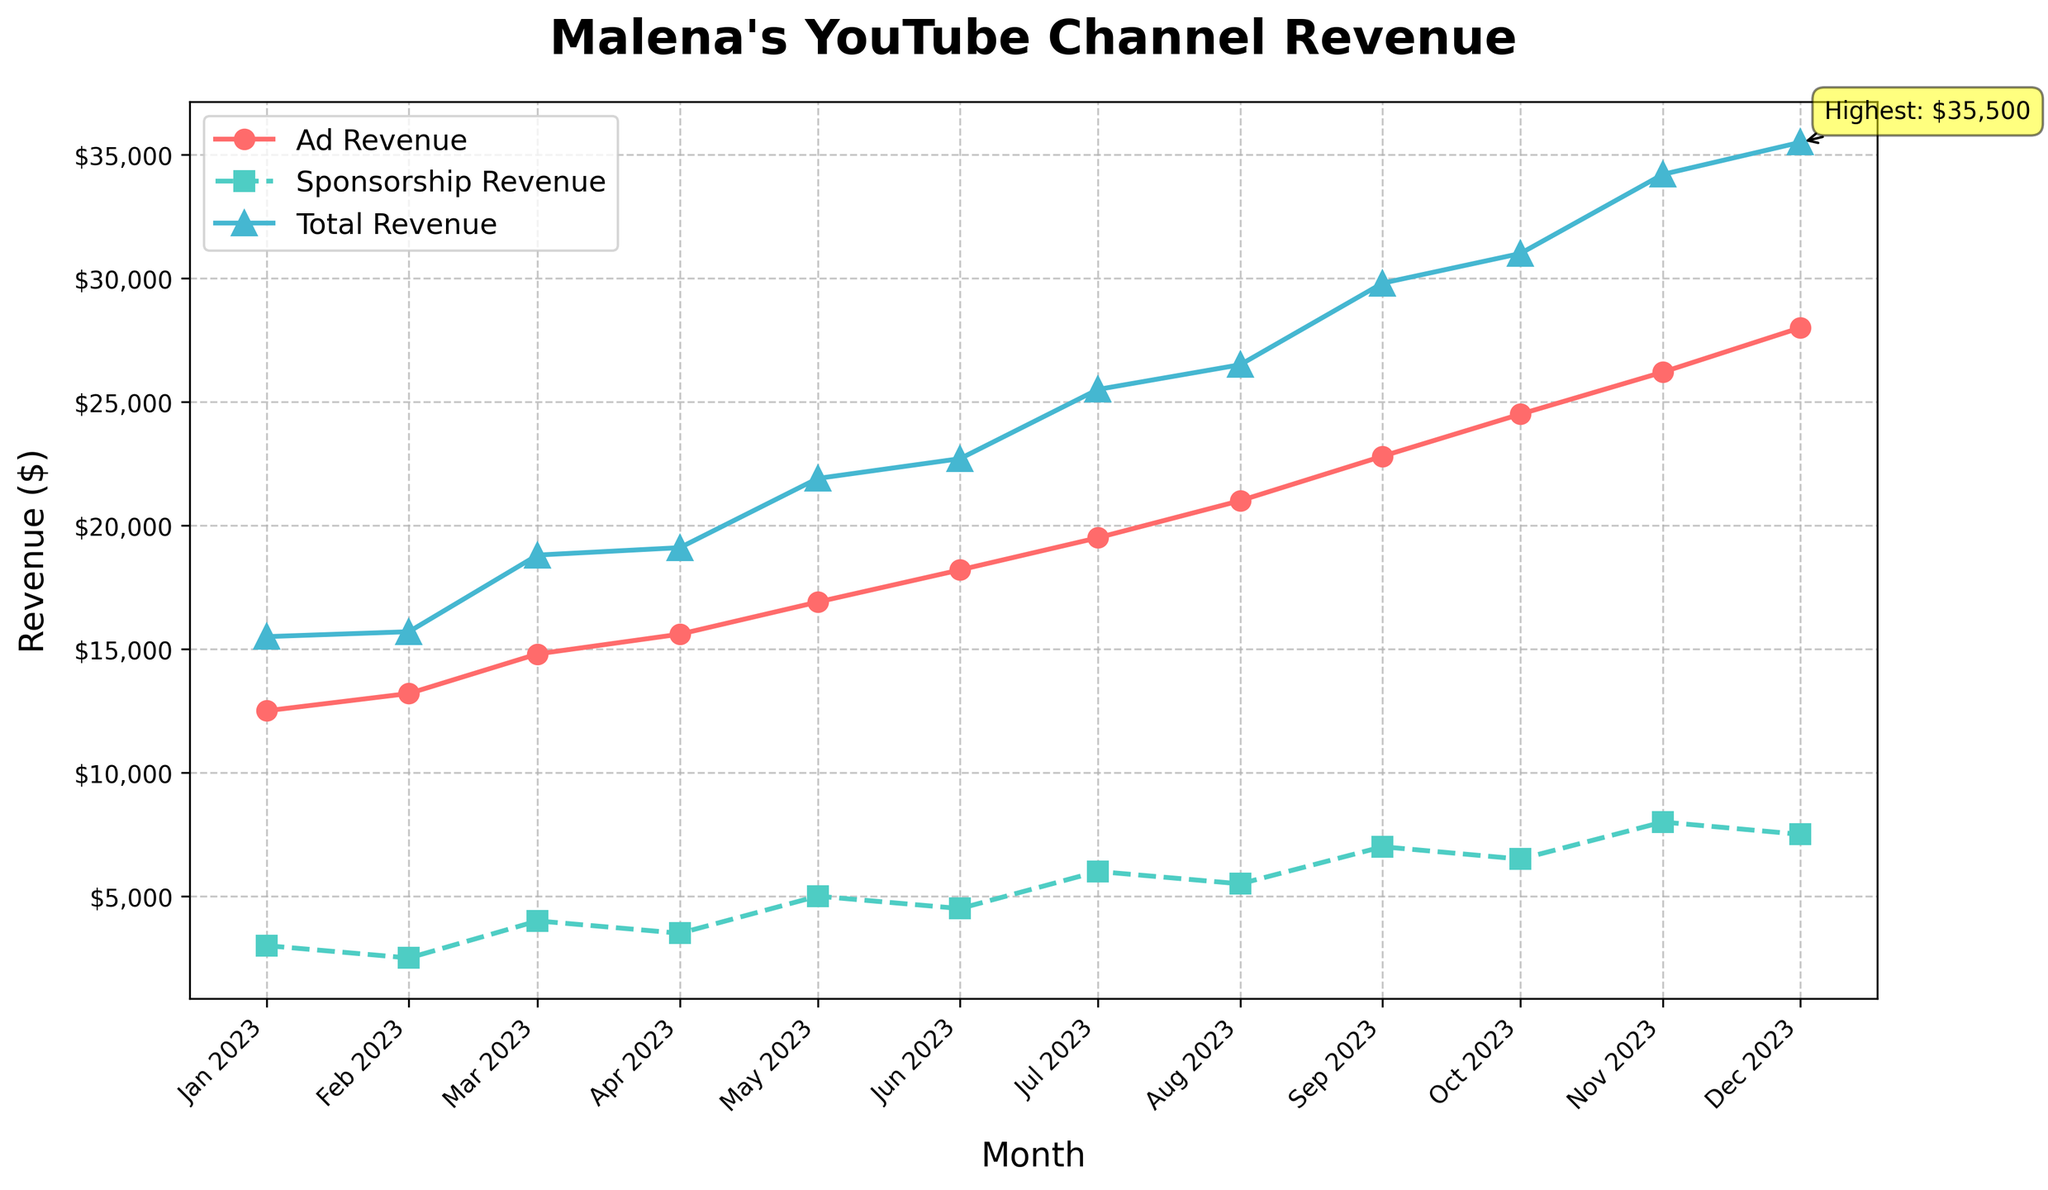What's the total revenue for December 2023? According to the plot, the total revenue for each month is marked with a line and an upward-pointing triangle. The revenue for December 2023 is indicated, which is $35,500.
Answer: $35,500 Which month had the highest total revenue? By looking at the plot, the total revenue in December 2023 is the highest, indicated by a special annotation on the graph pointing to this data point.
Answer: December 2023 What is the difference between Ad Revenue and Sponsorship Revenue for July 2023? In July 2023, the Ad Revenue is $19,500, and Sponsorship Revenue is $6,000. The difference is calculated as $19,500 - $6,000 = $13,500.
Answer: $13,500 Which month showed the highest spike in Total Revenue compared to the previous month? The highest spike can be observed by visually measuring the steepest upward slope. The largest increase is between November 2023 ($34,200) and December 2023 ($35,500), calculated as $35,500 - $34,200 = $3,300.
Answer: December 2023 How much did Malena's Sponsorship Revenue increase from February 2023 to March 2023? In February 2023, Sponsorship Revenue was $2,500, and in March 2023, it increased to $4,000. The increase is calculated as $4,000 - $2,500 = $1,500.
Answer: $1,500 What is the average Ad Revenue from January to June 2023? The Ad Revenue from January to June 2023 is $12,500, $13,200, $14,800, $15,600, $16,900, and $18,200. The average is calculated as ($12,500 + $13,200 + $14,800 + $15,600 + $16,900 + $18,200) / 6 = $15,200.
Answer: $15,200 Compare the growth trends of Ad Revenue and Sponsorship Revenue from August to December 2023, which one grew faster? Visually, the Ad Revenue and Sponsorship Revenue both show an upward trend. Calculating the difference: Ad Revenue from August to December increased from $21,000 to $28,000 (+$7,000), while Sponsorship Revenue increased from $5,500 to $7,500 (+$2,000). Thus, Ad Revenue grew faster.
Answer: Ad Revenue In which month did Sponsorship Revenue first exceed $5,000? Looking at the plot, Sponsorship Revenue first exceeds $5,000 in May 2023 where it is marked at $5,000.
Answer: May 2023 What is the percentage increase in Total Revenue from June 2023 to July 2023? Total Revenue increased from $22,700 in June 2023 to $25,500 in July 2023. The percentage increase is calculated as (($25,500 - $22,700) / $22,700) * 100 ≈ 12.33%.
Answer: 12.33% Which month showed no increase in Sponsorship Revenue compared to the previous month? Observing the trend, in October 2023, Sponsorship Revenue was $6,500, which remained unchanged compared to September 2023.
Answer: October 2023 